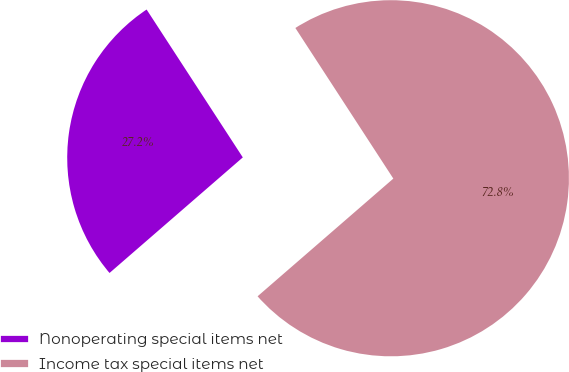Convert chart. <chart><loc_0><loc_0><loc_500><loc_500><pie_chart><fcel>Nonoperating special items net<fcel>Income tax special items net<nl><fcel>27.19%<fcel>72.81%<nl></chart> 